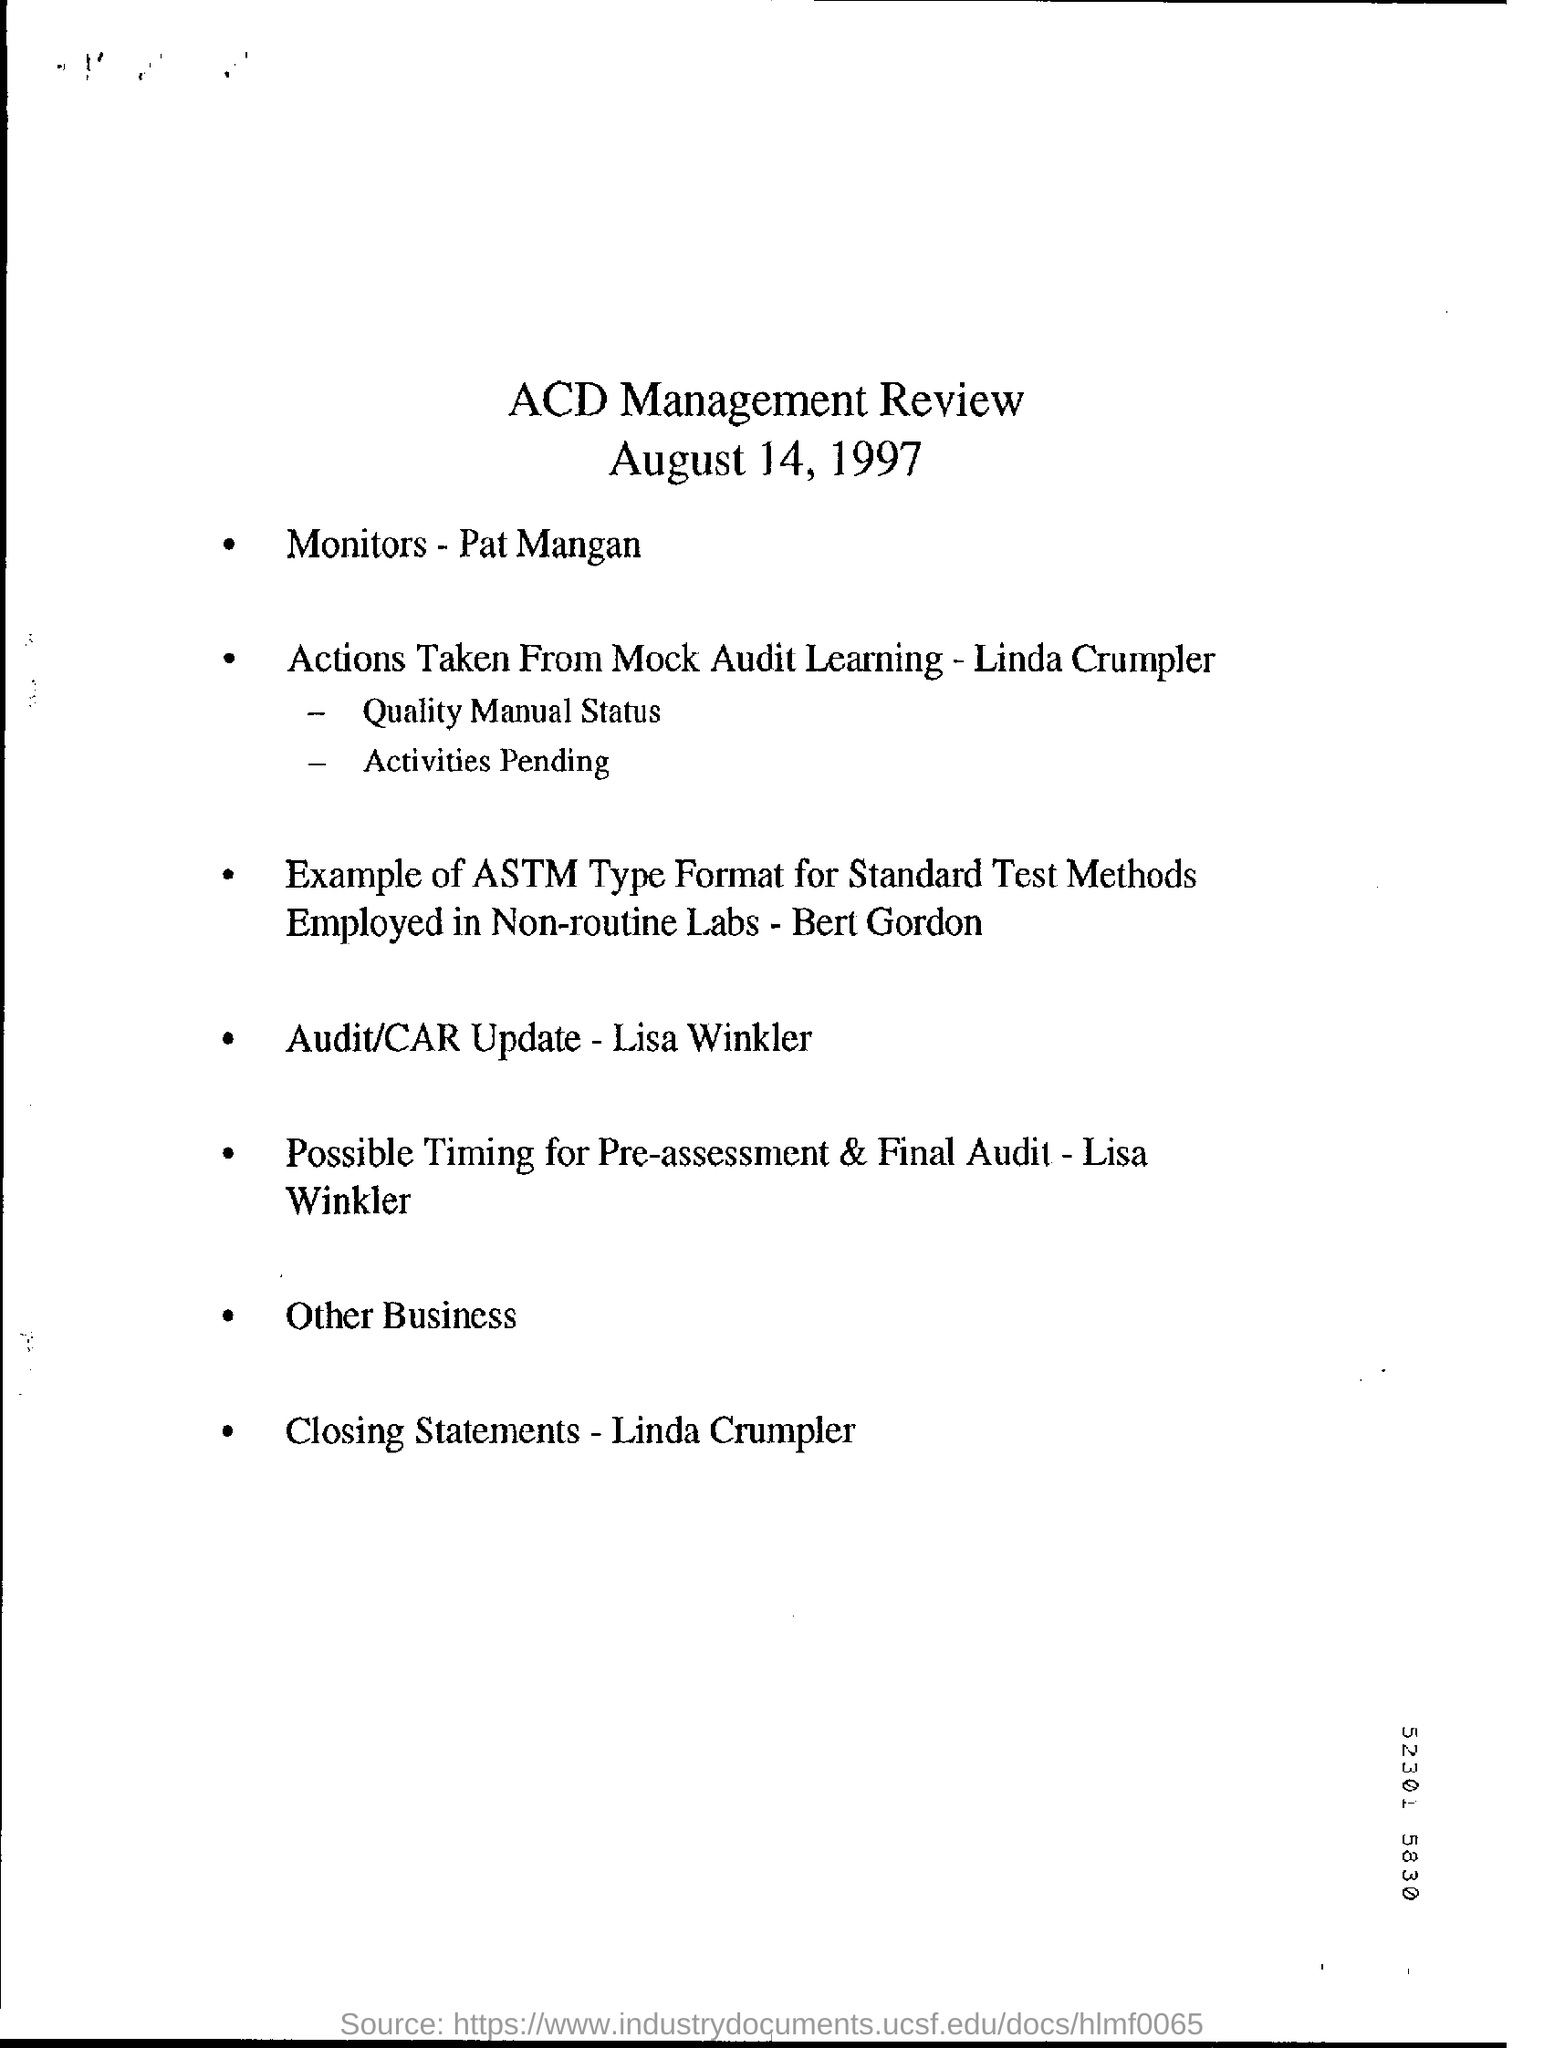What is the date on the document?
Offer a terse response. August 14, 1997. What is the Title of the document?
Give a very brief answer. ACD Management Review. 